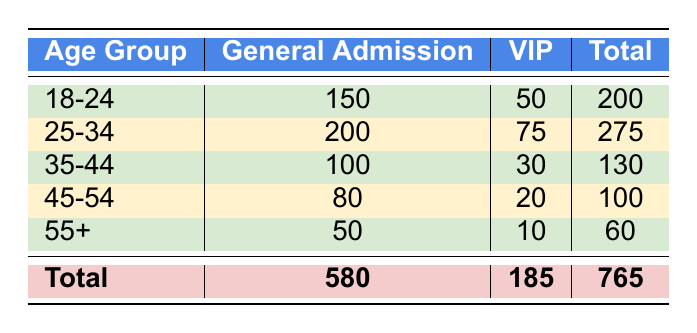What is the total number of attendees in the 18-24 age group? The total for the 18-24 age group can be found by adding the General Admission and VIP attendees: 150 (General Admission) + 50 (VIP) = 200.
Answer: 200 How many attendees purchased VIP tickets? To find the total VIP ticket attendees, we sum the numbers from the VIP column: 50 (18-24) + 75 (25-34) + 30 (35-44) + 20 (45-54) + 10 (55+) = 185.
Answer: 185 Which age group had the highest number of General Admission attendees? The age group with the highest count in the General Admission column is 25-34 with 200 attendees, which is higher than any other age group's General Admission tickets.
Answer: 25-34 Is the total number of General Admission attendees greater than the total number of VIP attendees? To compare, we see that the total for General Admission is 580 and for VIP is 185. Since 580 is greater than 185, the statement is true.
Answer: Yes What is the average number of attendees per age group for General Admission tickets? There are 5 age groups listed for General Admission. The total number of General Admission attendees is 580. To get the average, divide 580 by 5, which equals 116.
Answer: 116 What is the difference in the number of attendees between the 25-34 age group and the 45-54 age group? For the 25-34 age group, the total is 275 (200 General Admission + 75 VIP). For the 45-54 age group, the total is 100 (80 General Admission + 20 VIP). The difference is 275 - 100 = 175.
Answer: 175 Are there more attendees in the 35-44 age group or the 18-24 age group? The 35-44 age group has a total of 130 attendees (100 General Admission + 30 VIP) and the 18-24 age group has 200 attendees. Since 200 is greater than 130, the answer is 18-24 age group.
Answer: 18-24 What percentage of total attendees are from the 55+ age group? The total number of attendees is 765. The 55+ age group has 60 attendees. To find the percentage, divide 60 by 765 and multiply by 100, which gives approximately 7.84%.
Answer: 7.84% 